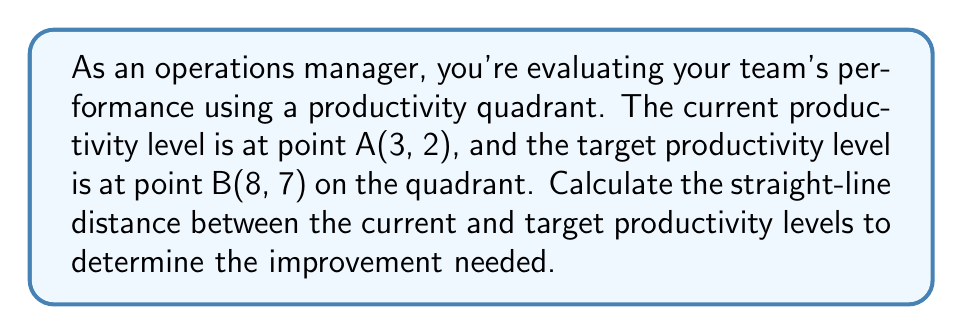Could you help me with this problem? To solve this problem, we need to use the distance formula between two points in a coordinate plane. The distance formula is derived from the Pythagorean theorem and is given by:

$$ d = \sqrt{(x_2 - x_1)^2 + (y_2 - y_1)^2} $$

Where $(x_1, y_1)$ is the first point and $(x_2, y_2)$ is the second point.

In our case:
- Point A (current productivity): $(x_1, y_1) = (3, 2)$
- Point B (target productivity): $(x_2, y_2) = (8, 7)$

Let's substitute these values into the formula:

$$ d = \sqrt{(8 - 3)^2 + (7 - 2)^2} $$

Now, let's solve step by step:

1) Simplify the expressions inside the parentheses:
   $$ d = \sqrt{5^2 + 5^2} $$

2) Calculate the squares:
   $$ d = \sqrt{25 + 25} $$

3) Add the values under the square root:
   $$ d = \sqrt{50} $$

4) Simplify the square root:
   $$ d = 5\sqrt{2} $$

This result, $5\sqrt{2}$, represents the straight-line distance between the current and target productivity levels in the performance quadrant.
Answer: The distance between the current and target productivity levels is $5\sqrt{2}$ units. 